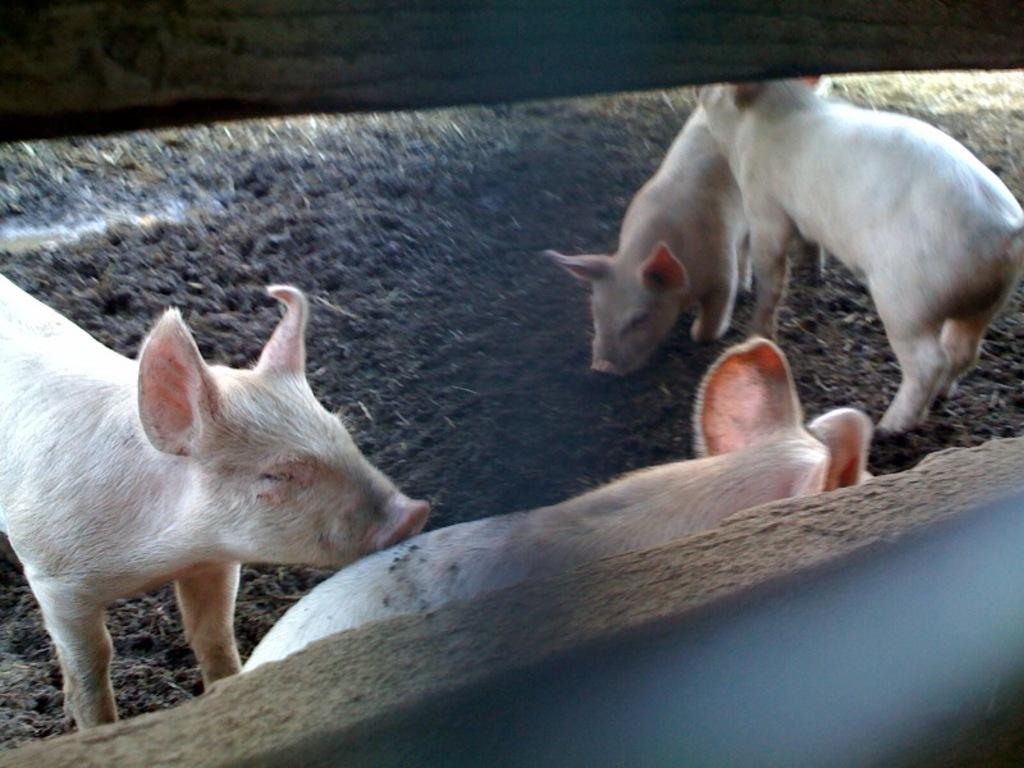How many pigs are present in the image? There are four pigs in the image. What are the pigs doing in the image? The pigs are standing on the ground. What can be seen in the background of the image? There is a fence in the image. What type of bomb can be seen in the image? There is no bomb present in the image; it features four pigs standing on the ground with a fence in the background. 